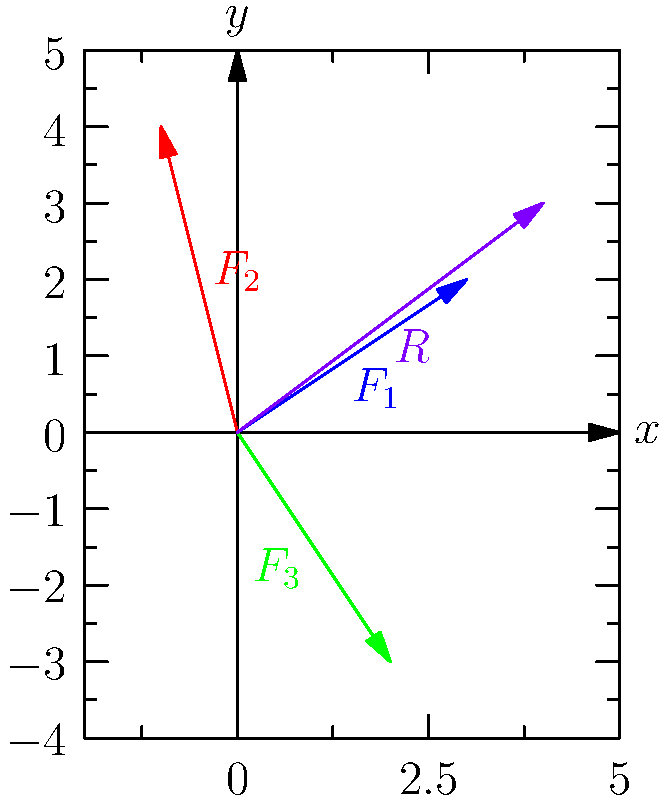As a technician analyzing forces acting on an artifact, you encounter three vectors: $F_1 = 3\hat{i} + 2\hat{j}$, $F_2 = -1\hat{i} + 4\hat{j}$, and $F_3 = 2\hat{i} - 3\hat{j}$. Calculate the magnitude of the resultant force vector $R$ acting on the artifact. To find the magnitude of the resultant force vector, we'll follow these steps:

1) First, we need to find the components of the resultant vector $R$. We do this by adding the corresponding components of the given vectors:

   $R_x = 3 + (-1) + 2 = 4$
   $R_y = 2 + 4 + (-3) = 3$

   So, $R = 4\hat{i} + 3\hat{j}$

2) Now that we have the components of $R$, we can calculate its magnitude using the Pythagorean theorem:

   $|R| = \sqrt{R_x^2 + R_y^2}$

3) Substituting the values:

   $|R| = \sqrt{4^2 + 3^2}$

4) Simplify:

   $|R| = \sqrt{16 + 9} = \sqrt{25} = 5$

Therefore, the magnitude of the resultant force vector $R$ is 5 units.
Answer: 5 units 